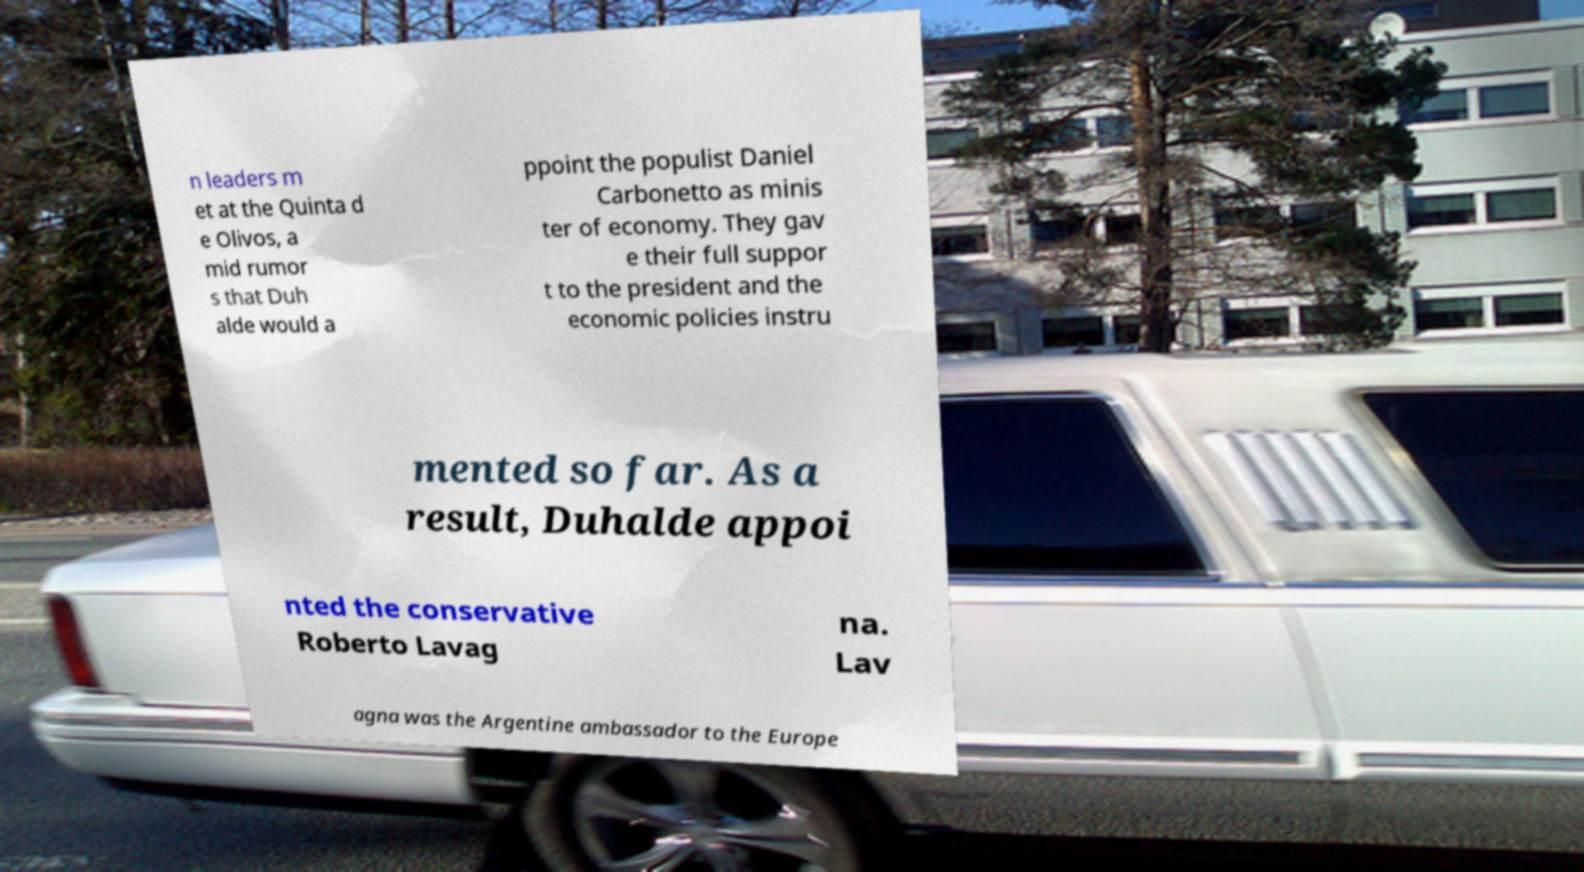Can you accurately transcribe the text from the provided image for me? n leaders m et at the Quinta d e Olivos, a mid rumor s that Duh alde would a ppoint the populist Daniel Carbonetto as minis ter of economy. They gav e their full suppor t to the president and the economic policies instru mented so far. As a result, Duhalde appoi nted the conservative Roberto Lavag na. Lav agna was the Argentine ambassador to the Europe 